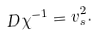Convert formula to latex. <formula><loc_0><loc_0><loc_500><loc_500>D \chi ^ { - 1 } = v _ { s } ^ { 2 } .</formula> 